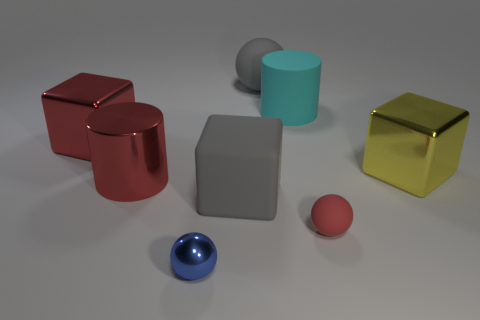What is the color of the cylinder that is behind the big metallic cube on the left side of the small red rubber sphere that is on the right side of the big red metal cylinder? The cylinder located behind the large metallic cube, which is itself to the left of the small red rubber sphere adjacent to the big red metal cylinder, appears to be cyan in color. 